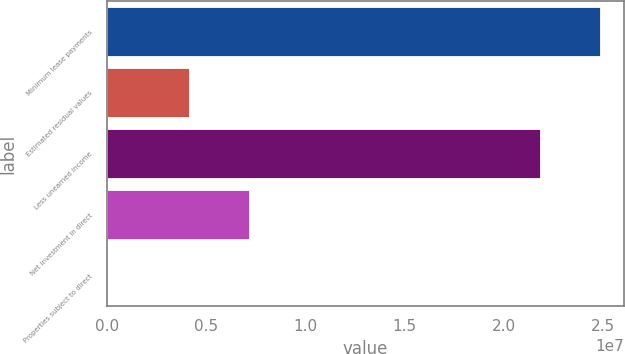<chart> <loc_0><loc_0><loc_500><loc_500><bar_chart><fcel>Minimum lease payments<fcel>Estimated residual values<fcel>Less unearned income<fcel>Net investment in direct<fcel>Properties subject to direct<nl><fcel>2.48084e+07<fcel>4.1344e+06<fcel>2.17894e+07<fcel>7.1534e+06<fcel>364<nl></chart> 